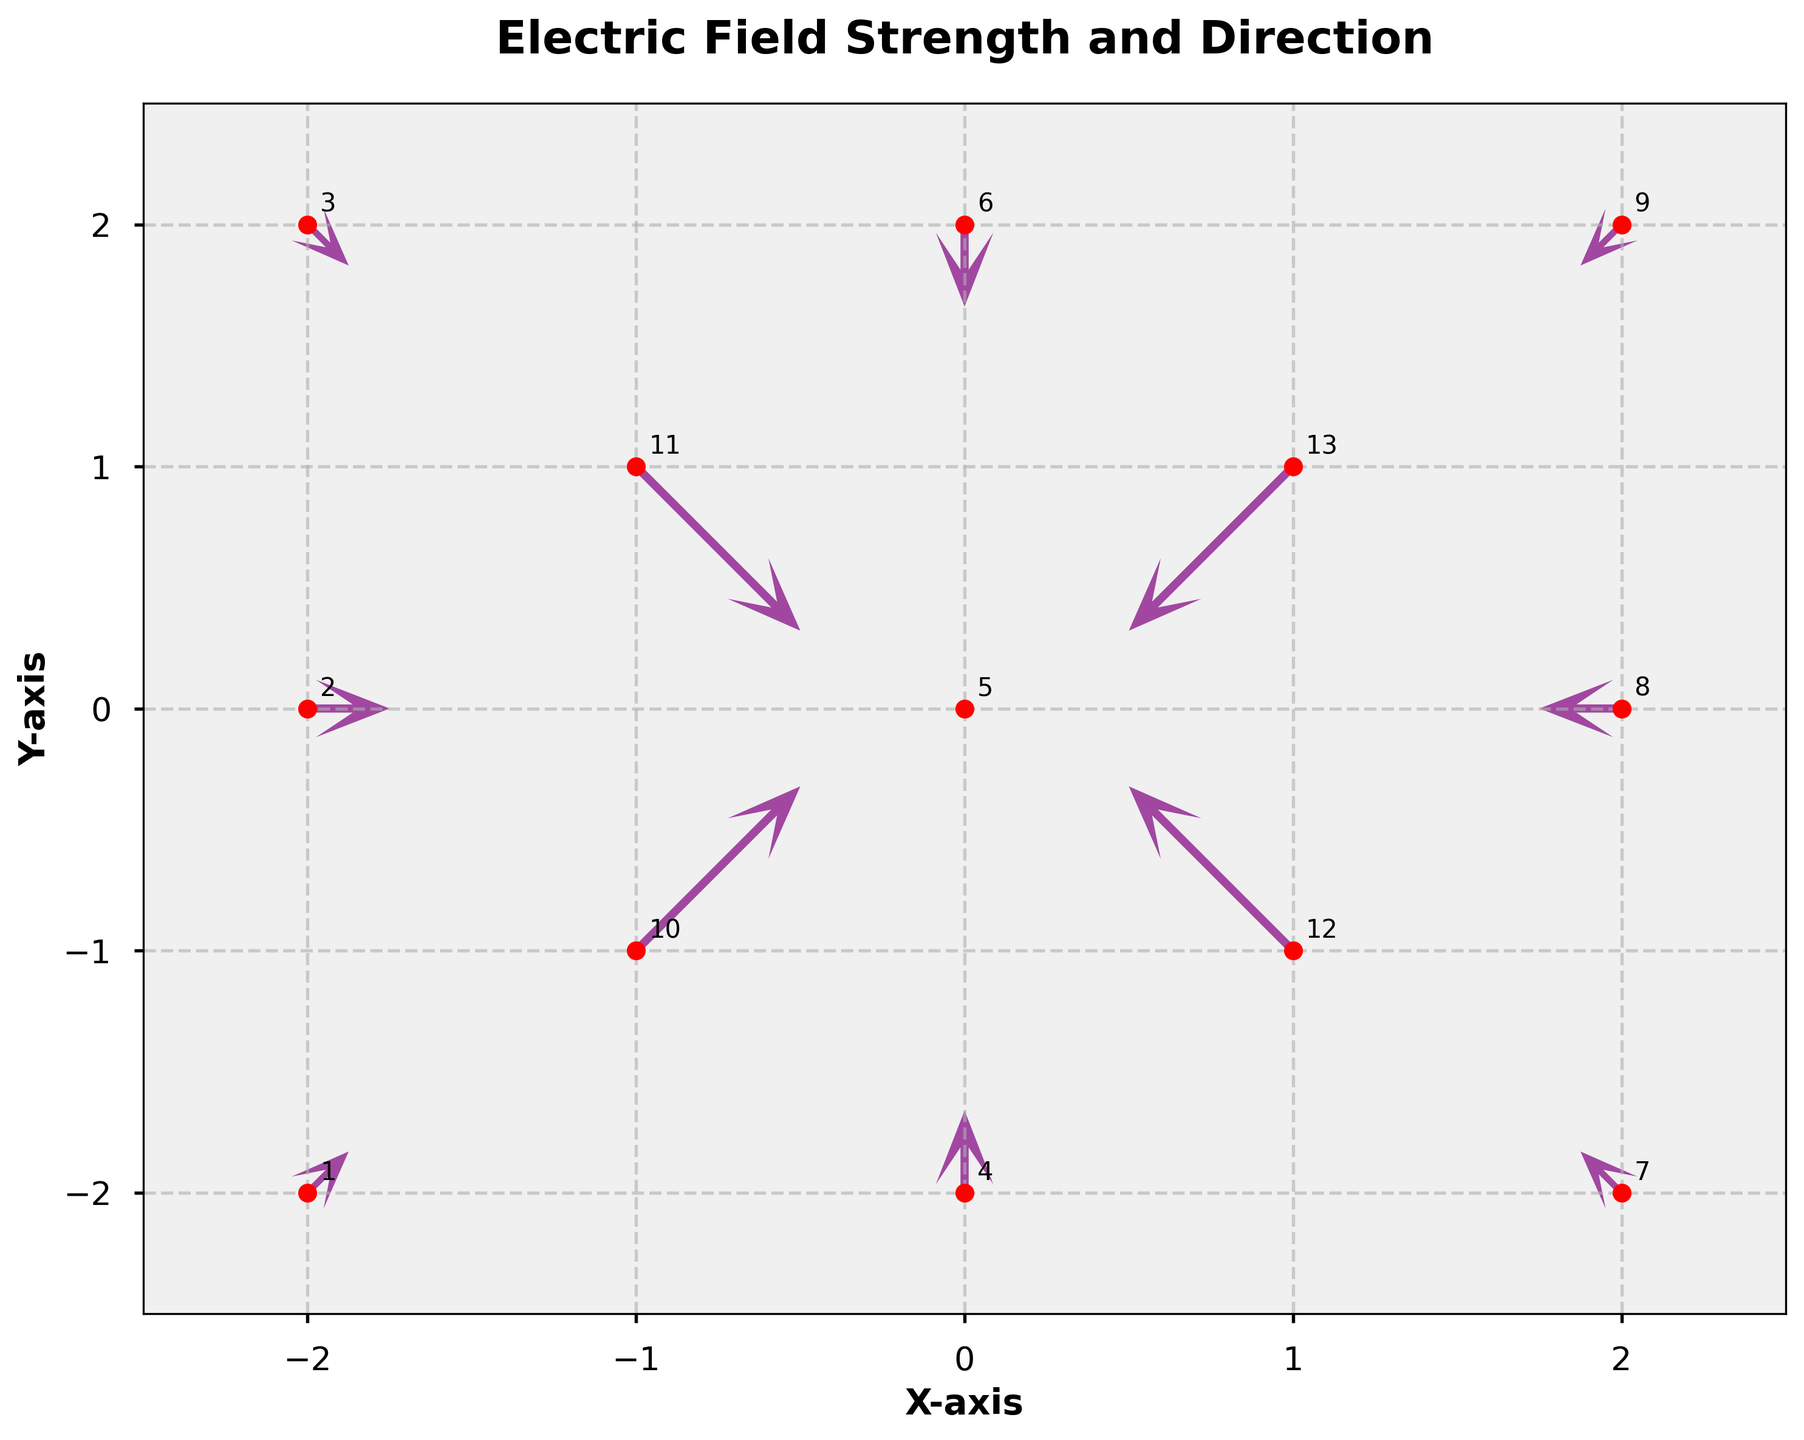What is the title of the plot? The title is located at the top of the plot, which is a standard place for titles in graphs. It should be straightforward to read.
Answer: Electric Field Strength and Direction How many data points are displayed as red dots on the plot? Count each red dot on the plot; each dot represents a data point in the given dataset.
Answer: 13 What are the axis labels in the figure? Look at the labels along the x-axis and y-axis, which are typically named to show what the respective axis represents.
Answer: X-axis and Y-axis What is the range of the x-axis? The range of the axes can be observed from the lower and upper ticks along the x-axis.
Answer: -2.5 to 2.5 What is the observed direction of the electric field at the point (1,1)? Locate the vector starting at the point (1,1) and note the direction it points.
Answer: Southwest Which vector has the longest magnitude, and where is it located? Compare the lengths of all vectors in the plot by visually inspecting them; the location can be determined by following each vector to its origin point.
Answer: At (-1, -1) and (-1, 1) What is the combined (summed) x-component of the electric field vectors at points (0,-2) and (2,0)? Look at the x-components of the vectors at (0,-2) and (2,0), which are 0 and -0.25, respectively, and sum them up.
Answer: -0.25 Which point has an electric field vector pointing north (upwards)? Identify vectors that point directly upward in the plot, indicating a direction toward the top of the page.
Answer: (0, -2) What is the average electric field strength at positions (0,2) and (-2,0)? Determine the magnitudes of the electric fields at these positions: (0,2) has a magnitude of 0.25, and (-2,0) has a magnitude of 0.25. Average them by summing and dividing by 2.
Answer: 0.25 How do the vectors at positions (-2,2) and (2,-2) compare in terms of direction? Look at the directions of both vectors; the vector at (-2,2) points southwest, and the vector at (2,-2) points northeast, noting that directions are opposite.
Answer: They are opposite 